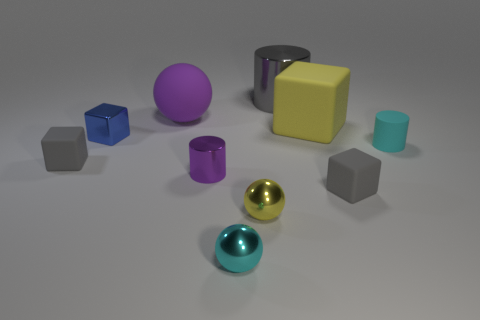Are there any yellow objects in front of the tiny yellow shiny sphere?
Make the answer very short. No. Are there any purple matte balls of the same size as the yellow metal object?
Provide a short and direct response. No. There is a ball that is made of the same material as the small cyan cylinder; what is its color?
Keep it short and to the point. Purple. What material is the blue cube?
Give a very brief answer. Metal. What shape is the small purple metallic object?
Offer a terse response. Cylinder. What number of rubber things are the same color as the matte cylinder?
Keep it short and to the point. 0. There is a cube in front of the rubber cube that is to the left of the tiny metal thing behind the cyan matte thing; what is it made of?
Give a very brief answer. Rubber. How many cyan things are either large matte blocks or metallic objects?
Your response must be concise. 1. How big is the object that is behind the purple thing that is behind the small cylinder on the left side of the tiny cyan shiny thing?
Your response must be concise. Large. The purple matte thing that is the same shape as the cyan metallic thing is what size?
Your answer should be very brief. Large. 